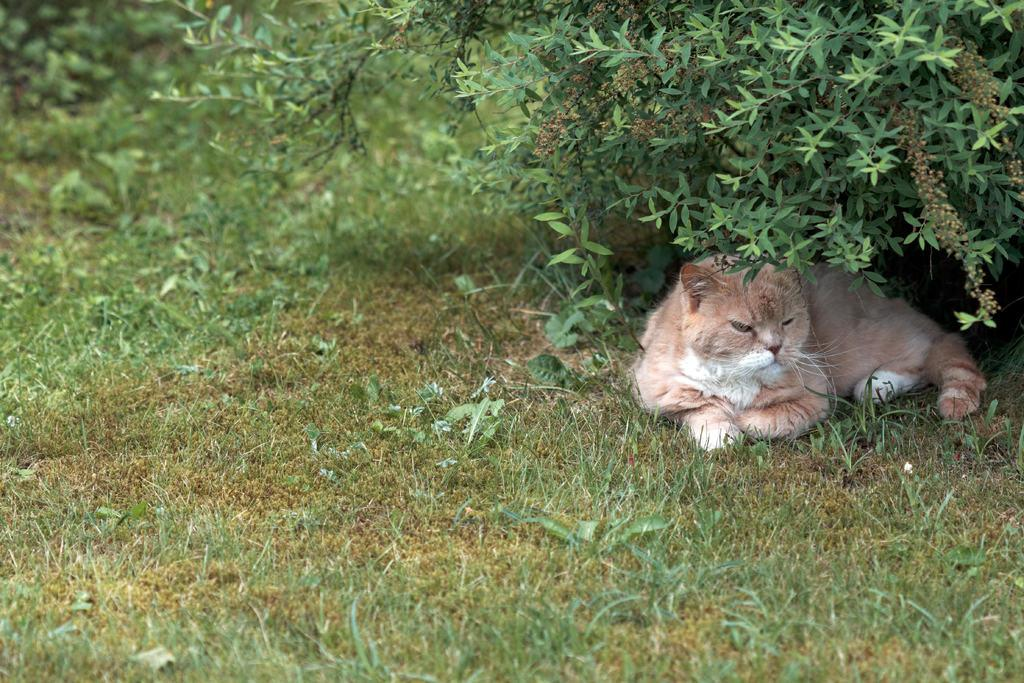What type of animal is in the image? There is a cat in the image. What can be seen in the background of the image? There are plants and grass in the background of the image. What is the bottom of the image composed of? The bottom of the image contains grass. What type of ground can be seen in the image? There is no ground visible in the image; it features a cat and plants in a grassy background. 